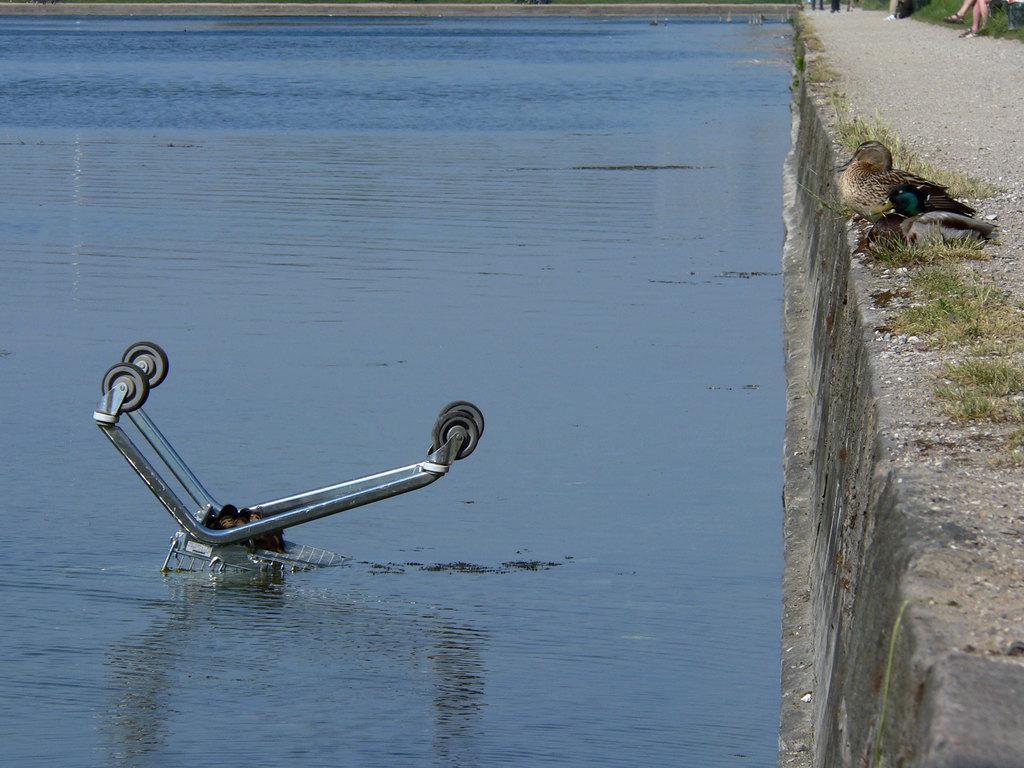Describe this image in one or two sentences. In this image I can see an object in the water. It is looking like a trolley wheel. On the right side there is a bird. 